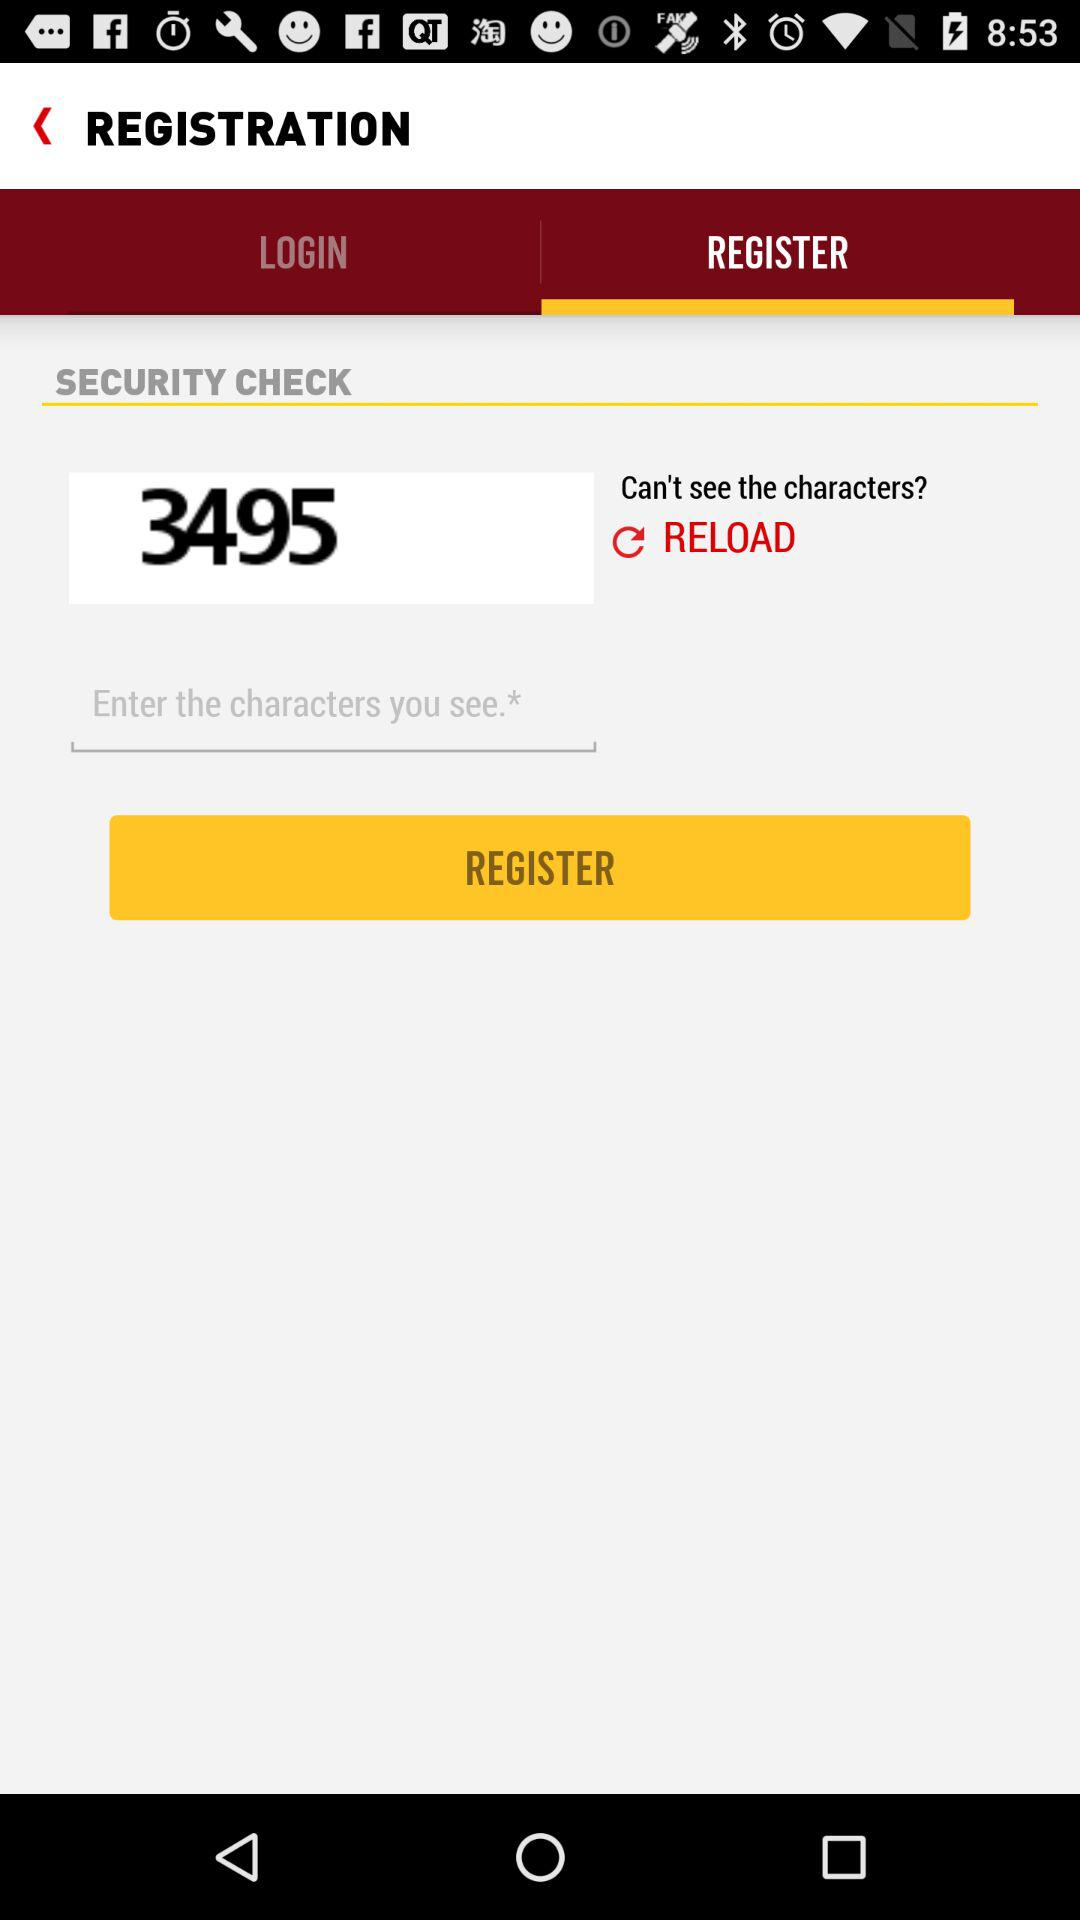Which tab has been selected? The selected tab is "REGISTER". 